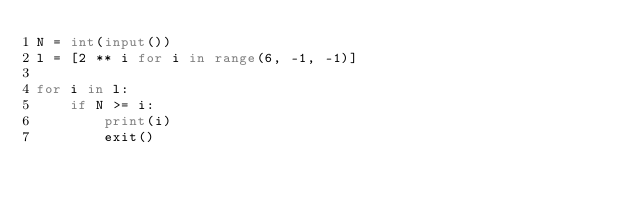Convert code to text. <code><loc_0><loc_0><loc_500><loc_500><_Python_>N = int(input())
l = [2 ** i for i in range(6, -1, -1)]

for i in l:
    if N >= i:
        print(i)
        exit()
</code> 